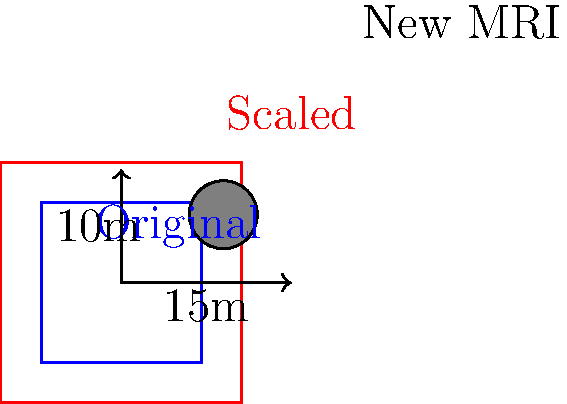As the team manager of a medical facility, you're tasked with accommodating a new MRI machine. The original floor plan of a square room measures 10m x 10m. If the room needs to be scaled up by a factor of 1.5 to fit the new equipment, what will be the area of the new scaled room, and by how many square meters will it increase? Let's approach this step-by-step:

1) First, let's calculate the area of the original room:
   Original area = $10\text{m} \times 10\text{m} = 100\text{m}^2$

2) Now, we need to scale this room by a factor of 1.5. In transformational geometry, when we scale a 2D shape, its area is affected by the square of the scale factor. So:
   New area = Original area $\times (\text{scale factor})^2$
   New area = $100\text{m}^2 \times (1.5)^2 = 100\text{m}^2 \times 2.25 = 225\text{m}^2$

3) To find the increase in area, we subtract the original area from the new area:
   Increase in area = New area - Original area
   Increase in area = $225\text{m}^2 - 100\text{m}^2 = 125\text{m}^2$

Therefore, the new scaled room will have an area of $225\text{m}^2$, and it will increase by $125\text{m}^2$.
Answer: $225\text{m}^2$; $125\text{m}^2$ increase 